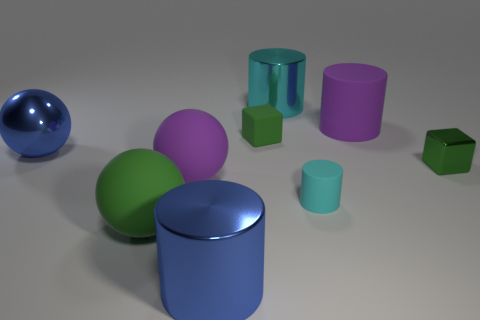What material is the sphere that is the same color as the metal cube?
Make the answer very short. Rubber. How many other matte objects have the same shape as the tiny cyan object?
Provide a succinct answer. 1. What is the material of the object that is to the right of the blue metal cylinder and in front of the green metallic object?
Make the answer very short. Rubber. There is a small green rubber object; how many small metallic cubes are behind it?
Your answer should be very brief. 0. What number of tiny brown things are there?
Your answer should be compact. 0. Is the size of the green rubber block the same as the purple matte cylinder?
Make the answer very short. No. Is there a large sphere behind the block in front of the tiny rubber block that is to the right of the big blue sphere?
Keep it short and to the point. Yes. There is another tiny cyan object that is the same shape as the cyan metallic thing; what is it made of?
Offer a terse response. Rubber. There is a metallic cylinder that is behind the small green rubber cube; what is its color?
Keep it short and to the point. Cyan. The matte cube has what size?
Offer a very short reply. Small. 